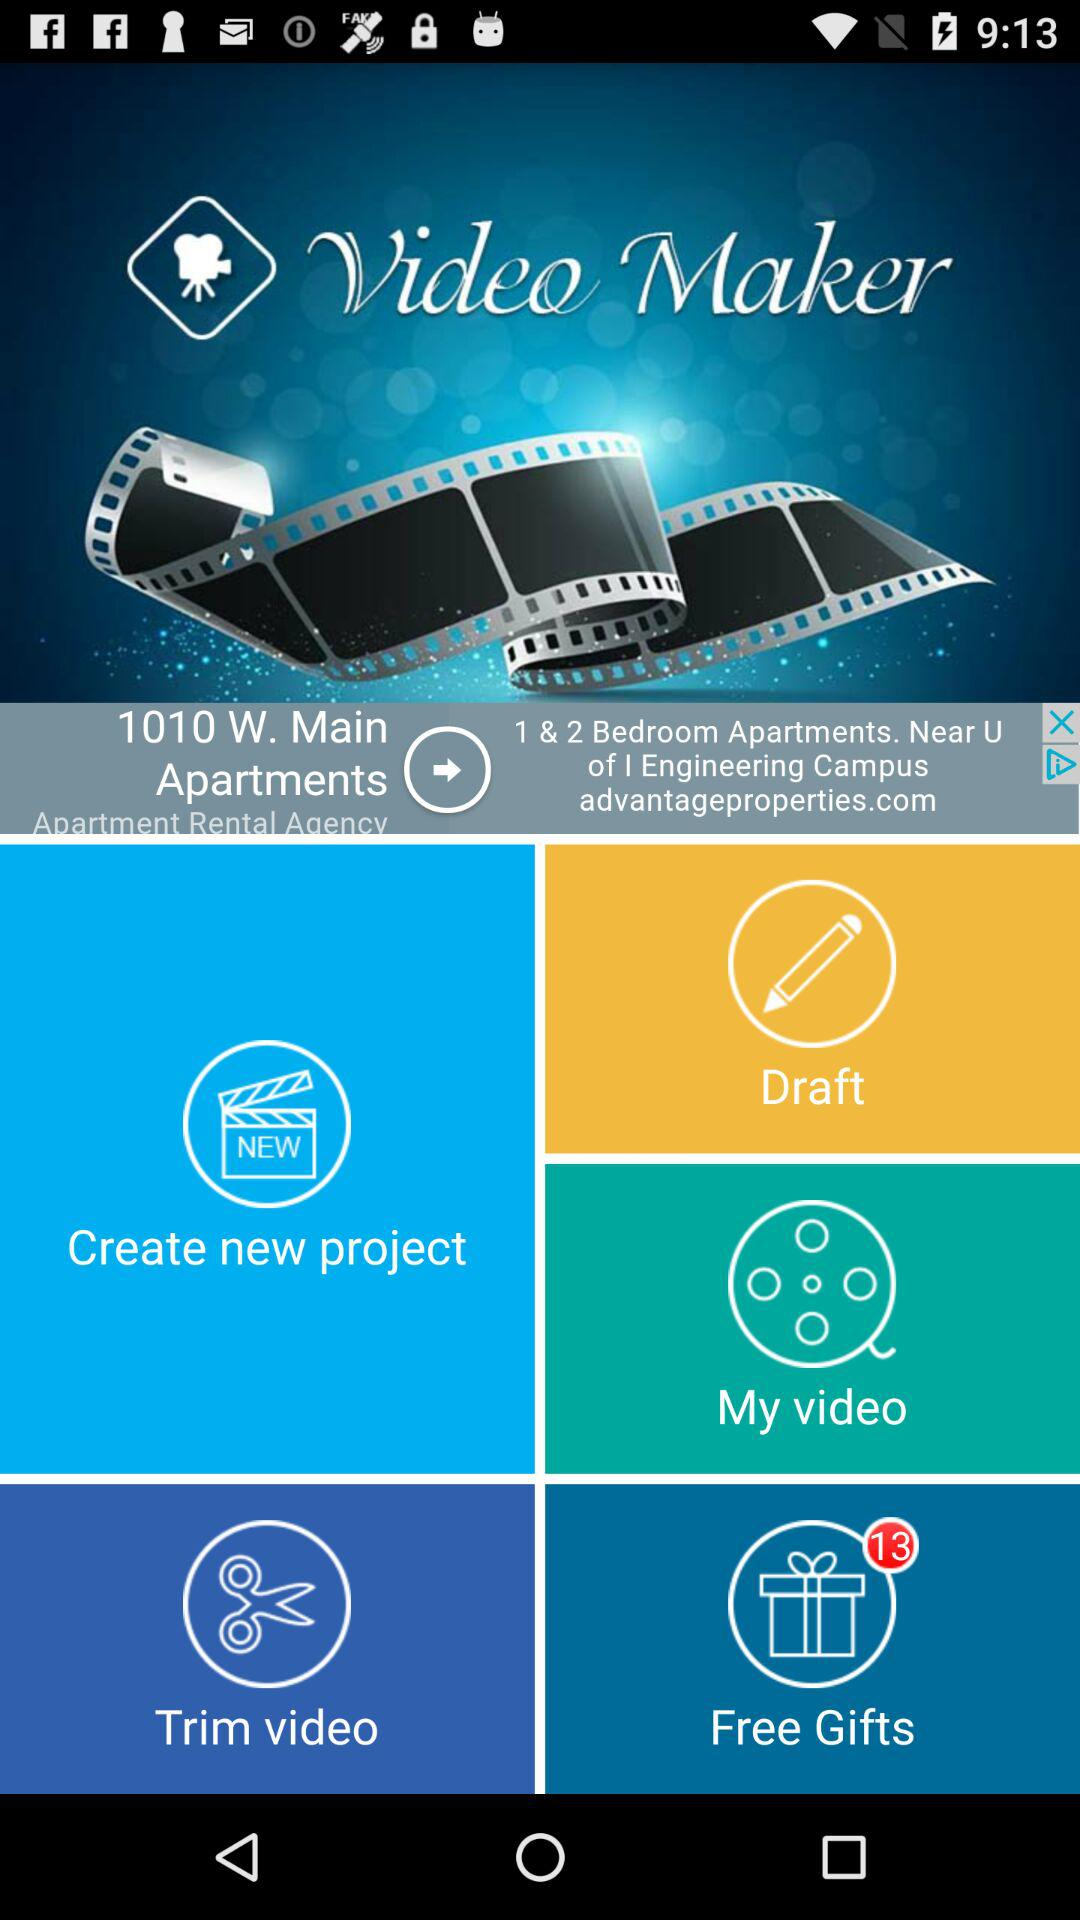What is the application name? The application name is "Video Maker". 